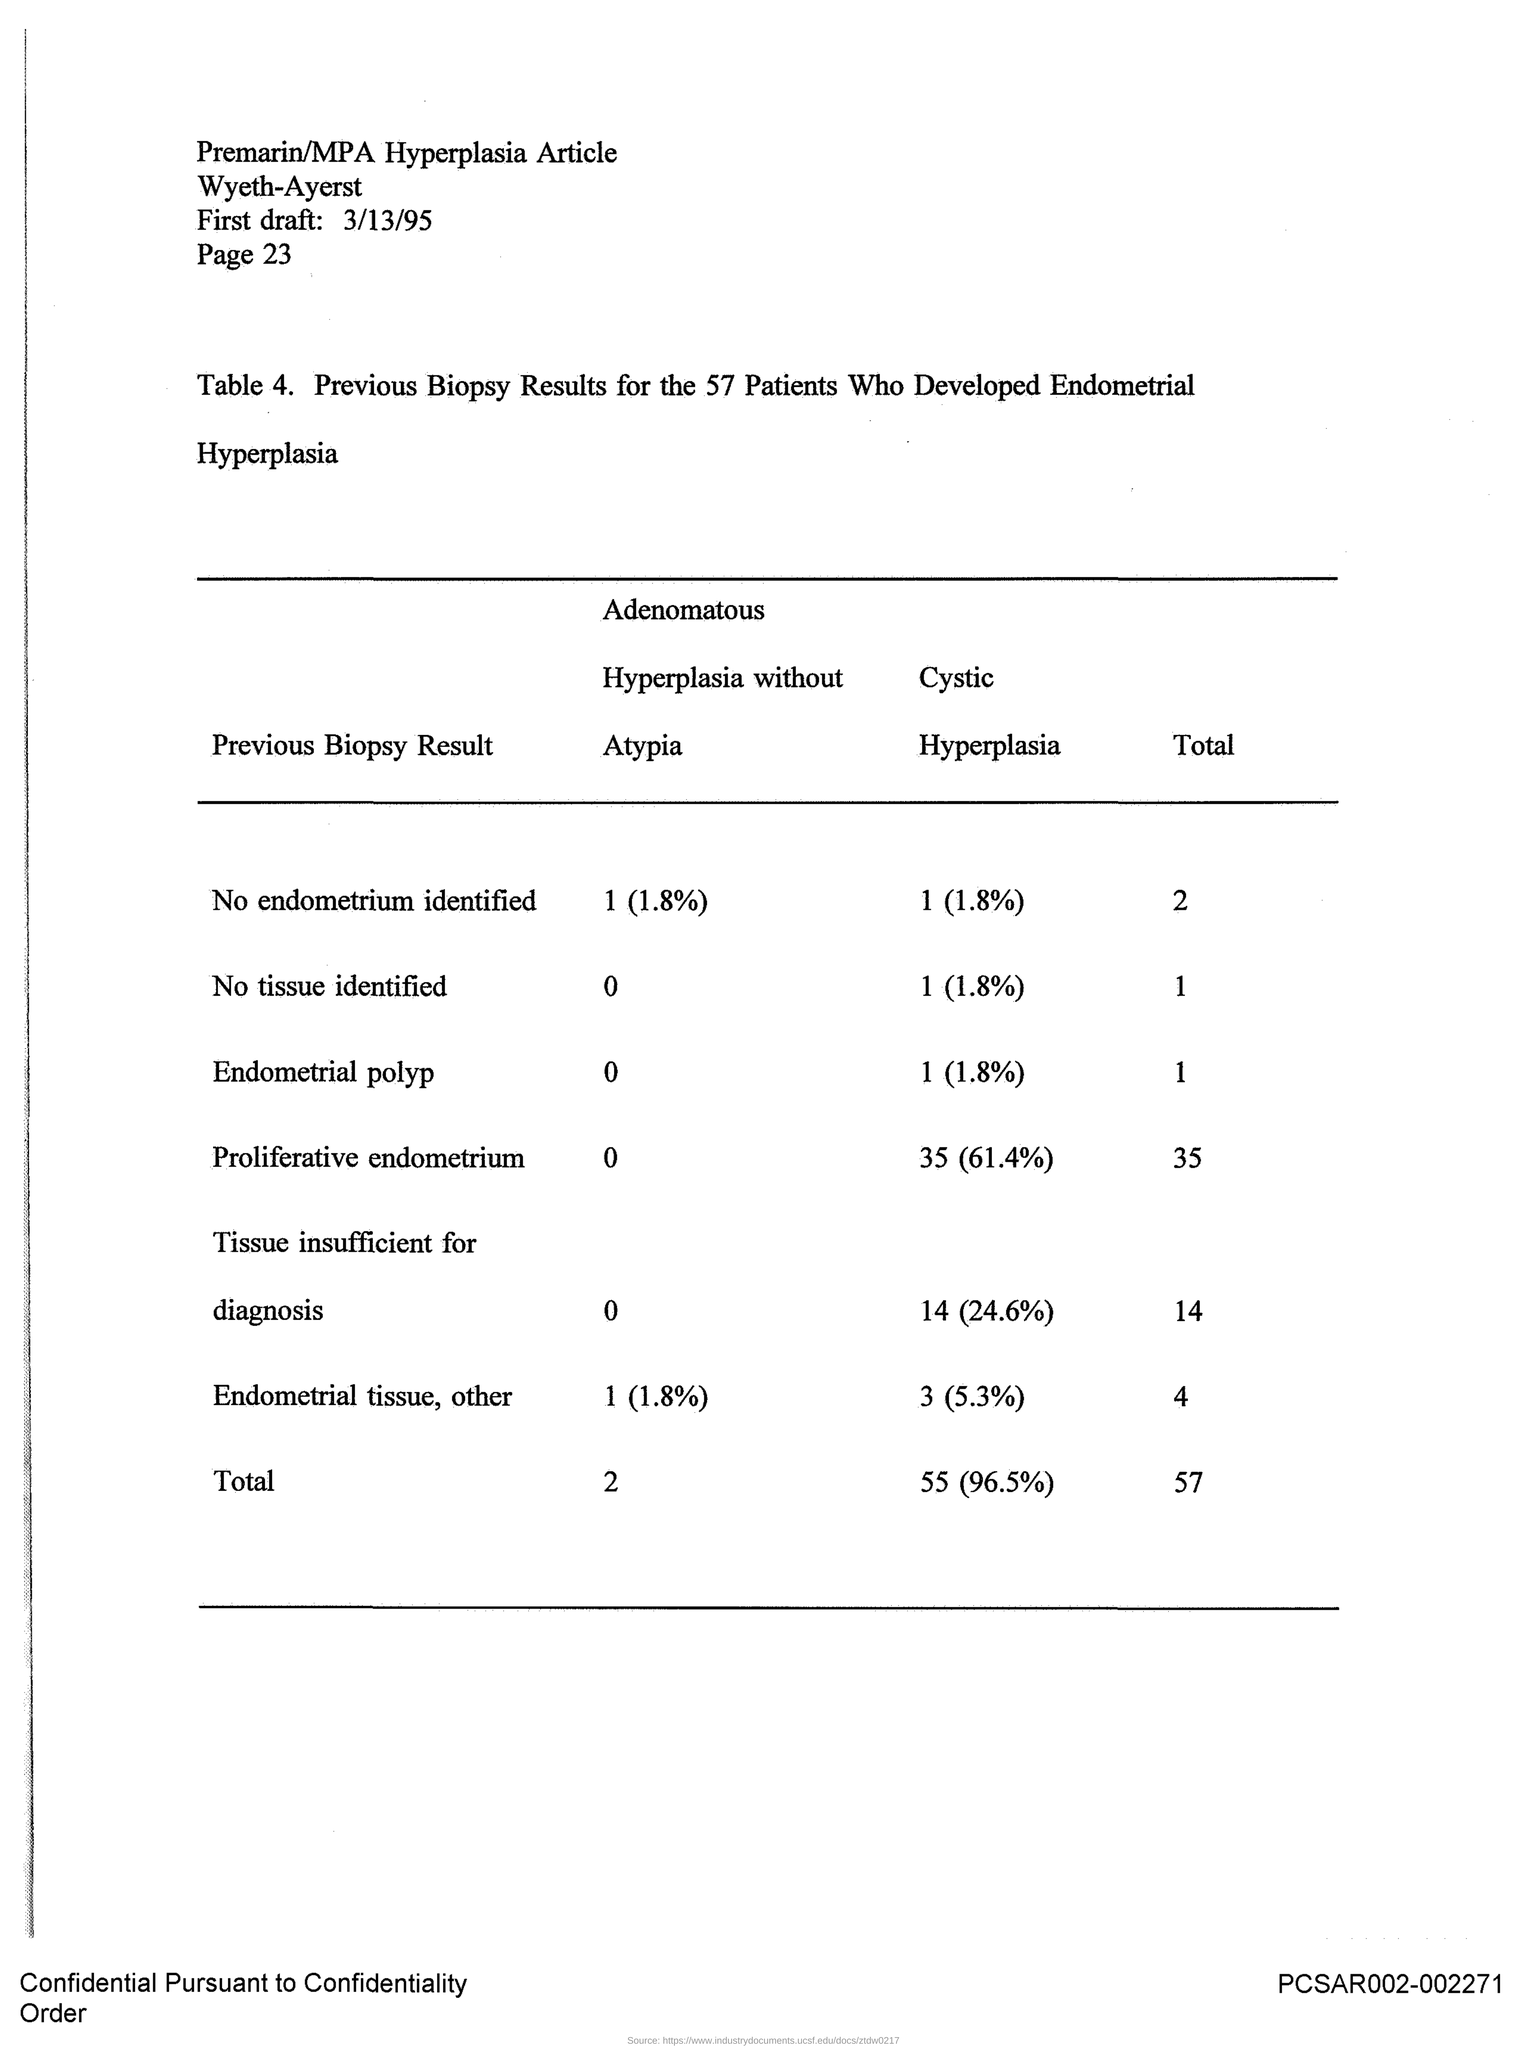Point out several critical features in this image. The biopsy results for 57 individuals are included in the document. 